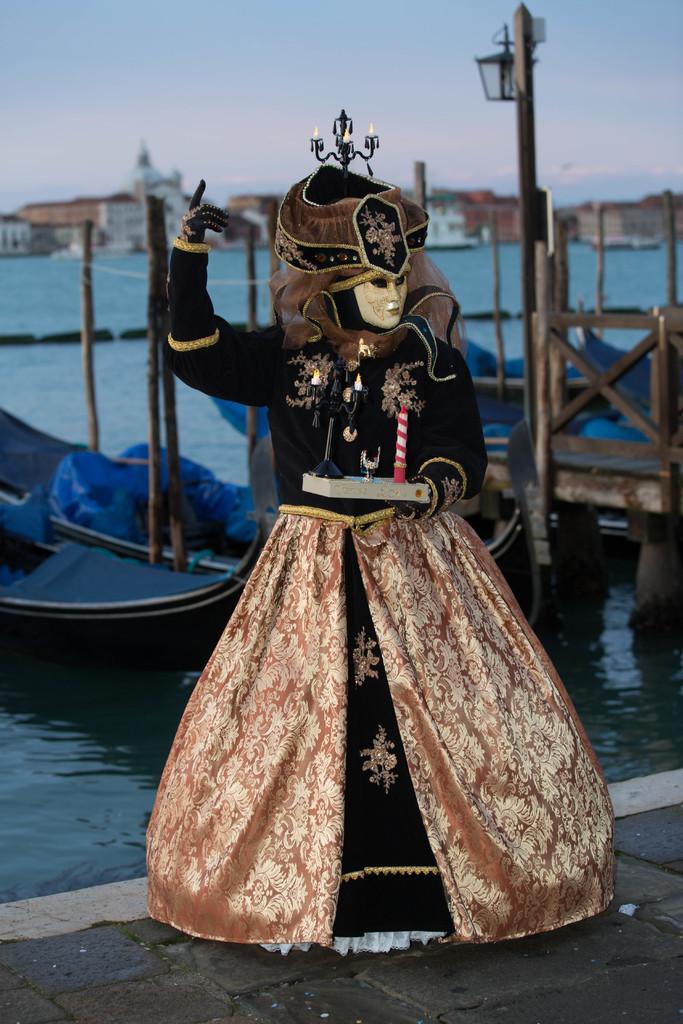Please provide a concise description of this image. In this image, we can see a toy and at the back of this toy there is a sea and there are also some houses. 